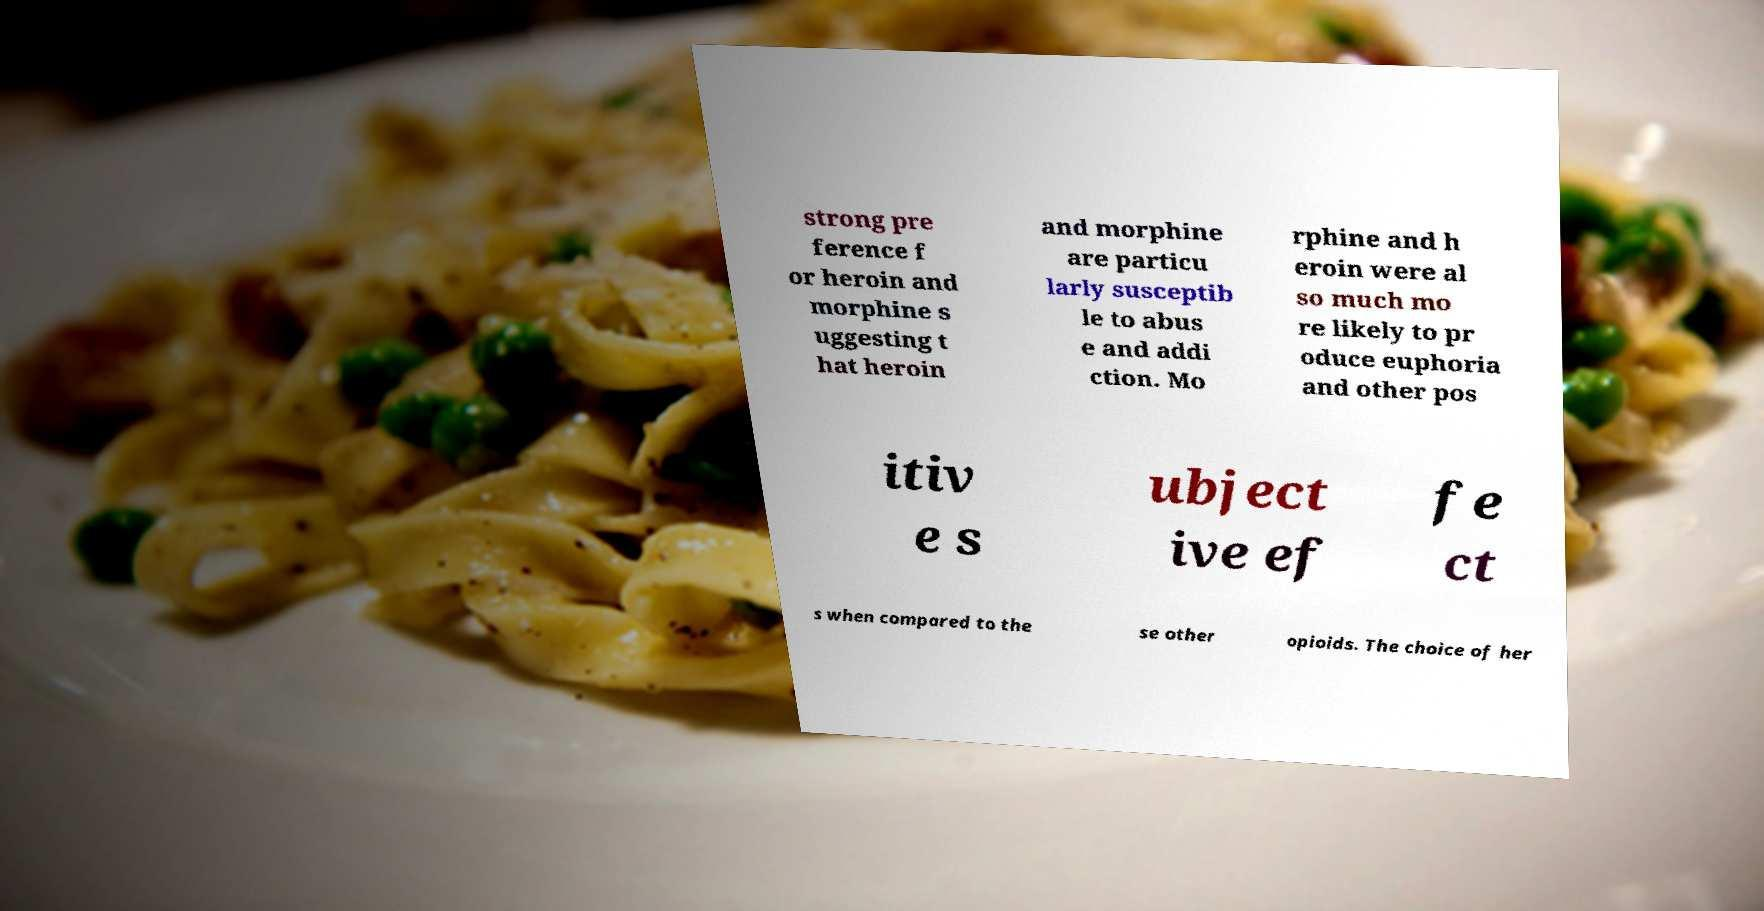Please read and relay the text visible in this image. What does it say? strong pre ference f or heroin and morphine s uggesting t hat heroin and morphine are particu larly susceptib le to abus e and addi ction. Mo rphine and h eroin were al so much mo re likely to pr oduce euphoria and other pos itiv e s ubject ive ef fe ct s when compared to the se other opioids. The choice of her 